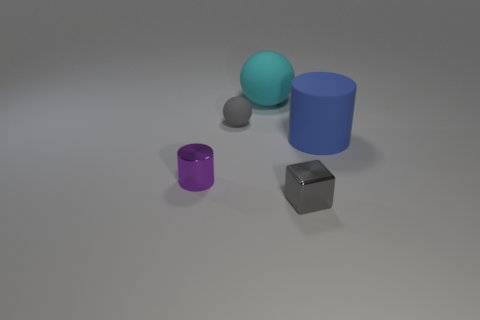Add 2 tiny brown matte spheres. How many objects exist? 7 Subtract 1 cylinders. How many cylinders are left? 1 Subtract all cylinders. How many objects are left? 3 Subtract all blue balls. Subtract all green cylinders. How many balls are left? 2 Subtract all large things. Subtract all large rubber objects. How many objects are left? 1 Add 4 metal cubes. How many metal cubes are left? 5 Add 4 big blue matte cylinders. How many big blue matte cylinders exist? 5 Subtract 0 green cylinders. How many objects are left? 5 